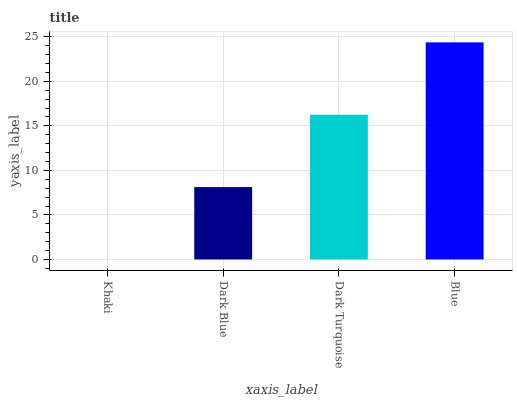Is Dark Blue the minimum?
Answer yes or no. No. Is Dark Blue the maximum?
Answer yes or no. No. Is Dark Blue greater than Khaki?
Answer yes or no. Yes. Is Khaki less than Dark Blue?
Answer yes or no. Yes. Is Khaki greater than Dark Blue?
Answer yes or no. No. Is Dark Blue less than Khaki?
Answer yes or no. No. Is Dark Turquoise the high median?
Answer yes or no. Yes. Is Dark Blue the low median?
Answer yes or no. Yes. Is Blue the high median?
Answer yes or no. No. Is Blue the low median?
Answer yes or no. No. 